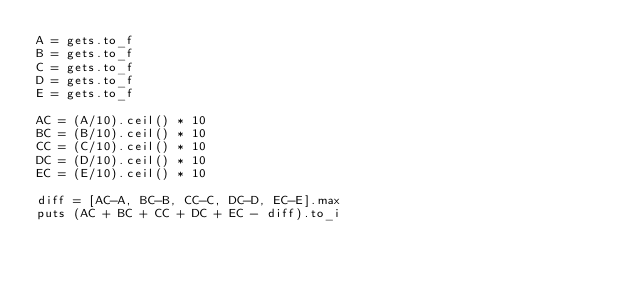<code> <loc_0><loc_0><loc_500><loc_500><_Ruby_>A = gets.to_f
B = gets.to_f
C = gets.to_f
D = gets.to_f
E = gets.to_f

AC = (A/10).ceil() * 10
BC = (B/10).ceil() * 10
CC = (C/10).ceil() * 10
DC = (D/10).ceil() * 10
EC = (E/10).ceil() * 10

diff = [AC-A, BC-B, CC-C, DC-D, EC-E].max
puts (AC + BC + CC + DC + EC - diff).to_i
</code> 